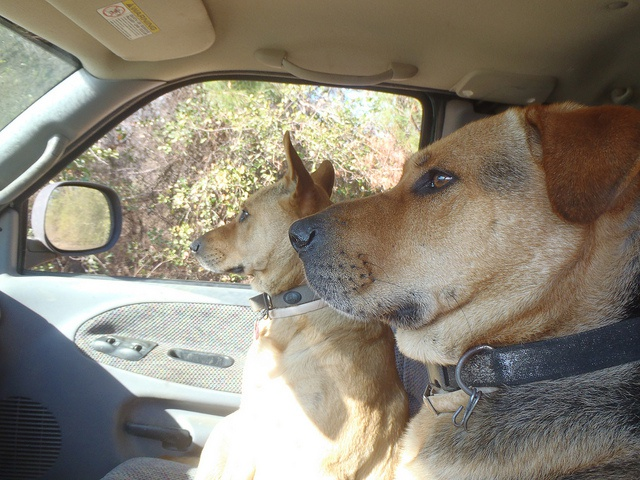Describe the objects in this image and their specific colors. I can see dog in gray, darkgray, and maroon tones and dog in gray, white, darkgray, and tan tones in this image. 